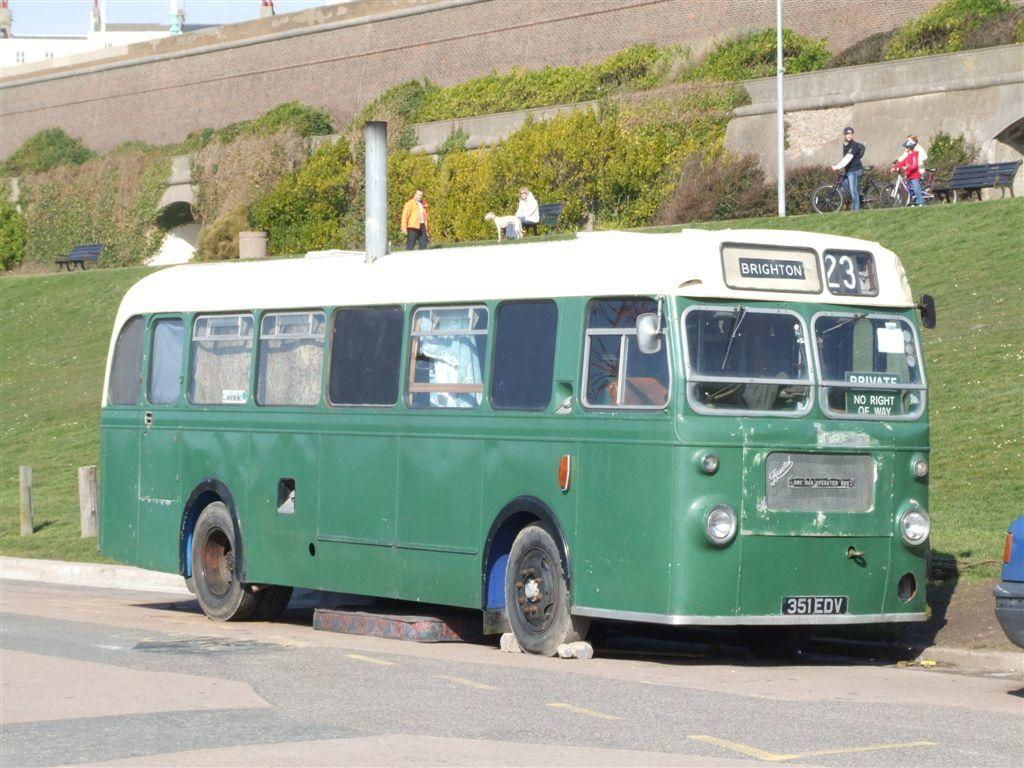Provide a one-sentence caption for the provided image. The signage indicates the green bus is the number 23 going to Brighton. 